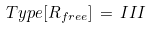<formula> <loc_0><loc_0><loc_500><loc_500>T y p e [ R _ { f r e e } ] \, = \, I I I</formula> 